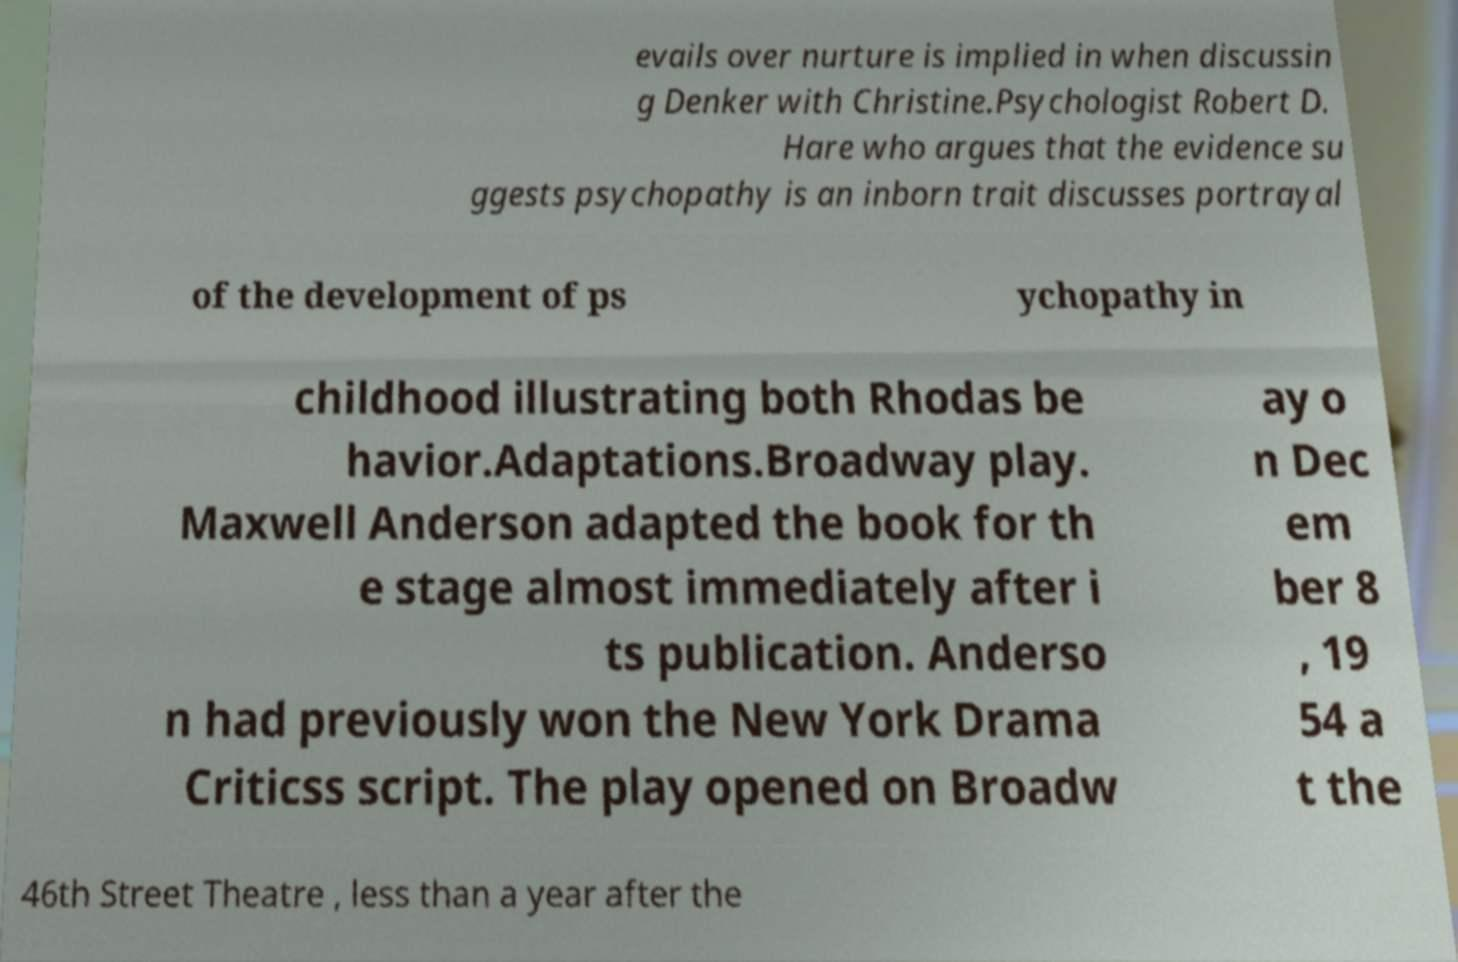I need the written content from this picture converted into text. Can you do that? evails over nurture is implied in when discussin g Denker with Christine.Psychologist Robert D. Hare who argues that the evidence su ggests psychopathy is an inborn trait discusses portrayal of the development of ps ychopathy in childhood illustrating both Rhodas be havior.Adaptations.Broadway play. Maxwell Anderson adapted the book for th e stage almost immediately after i ts publication. Anderso n had previously won the New York Drama Criticss script. The play opened on Broadw ay o n Dec em ber 8 , 19 54 a t the 46th Street Theatre , less than a year after the 